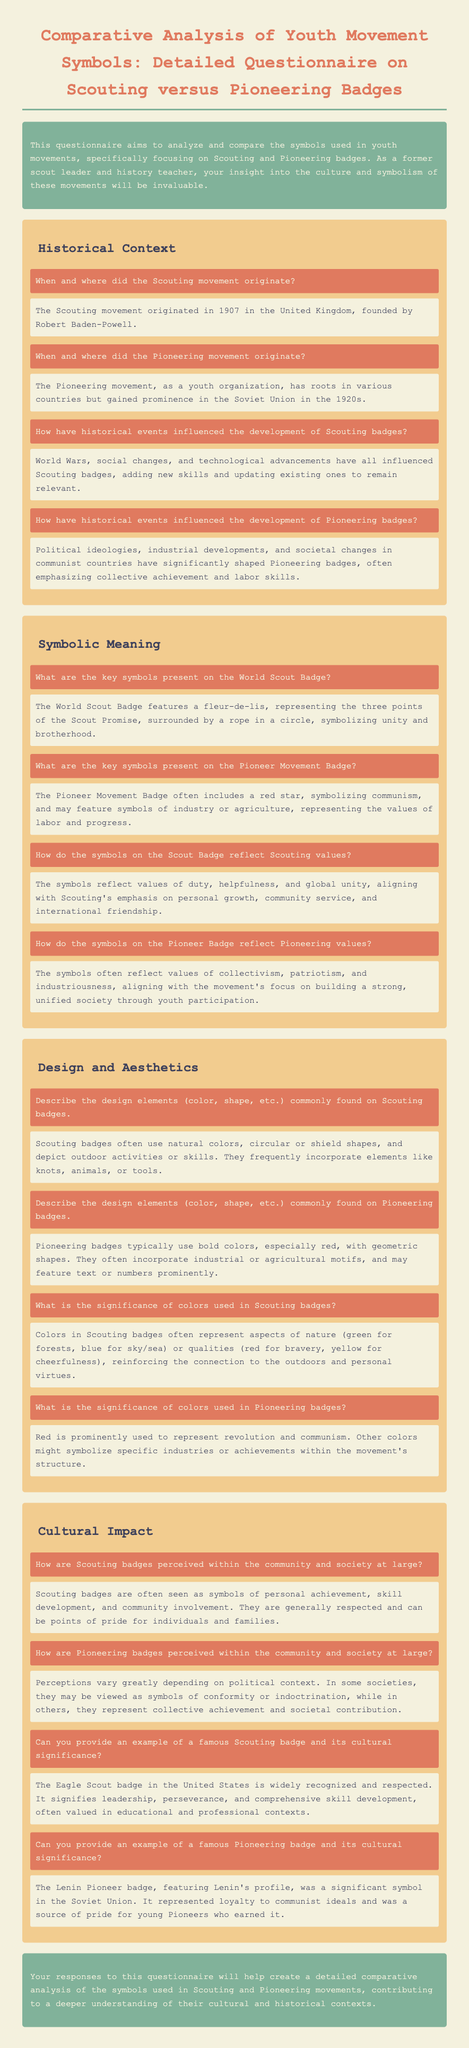What year did the Scouting movement originate? The document states that the Scouting movement originated in 1907.
Answer: 1907 What symbol is featured on the World Scout Badge? The document explains that the World Scout Badge features a fleur-de-lis.
Answer: fleur-de-lis What color is prominently used in Pioneering badges? The document notes that red is a prominent color in Pioneering badges.
Answer: red What is the significance of the Eagle Scout badge in the United States? The document describes the Eagle Scout badge as a symbol that signifies leadership, perseverance, and comprehensive skill development.
Answer: leadership, perseverance, comprehensive skill development How does the document describe the perception of Scouting badges? The document mentions that Scouting badges are often seen as symbols of personal achievement and community involvement.
Answer: personal achievement, community involvement 